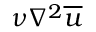<formula> <loc_0><loc_0><loc_500><loc_500>\nu \nabla ^ { 2 } \overline { u }</formula> 